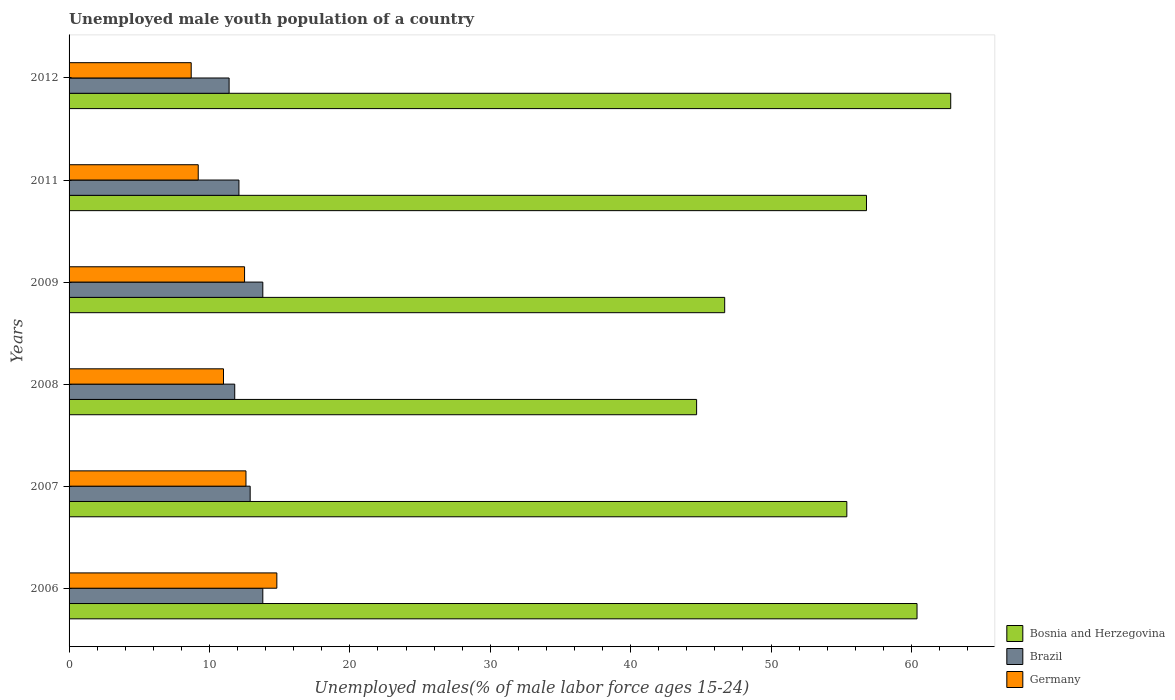How many groups of bars are there?
Ensure brevity in your answer.  6. Are the number of bars per tick equal to the number of legend labels?
Give a very brief answer. Yes. What is the label of the 4th group of bars from the top?
Your response must be concise. 2008. What is the percentage of unemployed male youth population in Bosnia and Herzegovina in 2009?
Offer a terse response. 46.7. Across all years, what is the maximum percentage of unemployed male youth population in Brazil?
Offer a very short reply. 13.8. Across all years, what is the minimum percentage of unemployed male youth population in Bosnia and Herzegovina?
Give a very brief answer. 44.7. In which year was the percentage of unemployed male youth population in Brazil maximum?
Ensure brevity in your answer.  2006. What is the total percentage of unemployed male youth population in Brazil in the graph?
Provide a short and direct response. 75.8. What is the difference between the percentage of unemployed male youth population in Brazil in 2008 and that in 2011?
Provide a short and direct response. -0.3. What is the difference between the percentage of unemployed male youth population in Brazil in 2011 and the percentage of unemployed male youth population in Bosnia and Herzegovina in 2007?
Your answer should be very brief. -43.3. What is the average percentage of unemployed male youth population in Germany per year?
Your answer should be very brief. 11.47. In the year 2012, what is the difference between the percentage of unemployed male youth population in Brazil and percentage of unemployed male youth population in Bosnia and Herzegovina?
Your answer should be very brief. -51.4. In how many years, is the percentage of unemployed male youth population in Bosnia and Herzegovina greater than 32 %?
Keep it short and to the point. 6. What is the ratio of the percentage of unemployed male youth population in Brazil in 2006 to that in 2008?
Make the answer very short. 1.17. What is the difference between the highest and the second highest percentage of unemployed male youth population in Bosnia and Herzegovina?
Your answer should be very brief. 2.4. What is the difference between the highest and the lowest percentage of unemployed male youth population in Bosnia and Herzegovina?
Provide a short and direct response. 18.1. In how many years, is the percentage of unemployed male youth population in Germany greater than the average percentage of unemployed male youth population in Germany taken over all years?
Offer a terse response. 3. Is the sum of the percentage of unemployed male youth population in Bosnia and Herzegovina in 2006 and 2009 greater than the maximum percentage of unemployed male youth population in Germany across all years?
Your answer should be very brief. Yes. What does the 2nd bar from the top in 2008 represents?
Give a very brief answer. Brazil. Are all the bars in the graph horizontal?
Your response must be concise. Yes. How many years are there in the graph?
Offer a very short reply. 6. What is the difference between two consecutive major ticks on the X-axis?
Offer a terse response. 10. Are the values on the major ticks of X-axis written in scientific E-notation?
Keep it short and to the point. No. Does the graph contain any zero values?
Give a very brief answer. No. Does the graph contain grids?
Offer a very short reply. No. What is the title of the graph?
Ensure brevity in your answer.  Unemployed male youth population of a country. What is the label or title of the X-axis?
Your response must be concise. Unemployed males(% of male labor force ages 15-24). What is the label or title of the Y-axis?
Make the answer very short. Years. What is the Unemployed males(% of male labor force ages 15-24) of Bosnia and Herzegovina in 2006?
Your response must be concise. 60.4. What is the Unemployed males(% of male labor force ages 15-24) of Brazil in 2006?
Your answer should be very brief. 13.8. What is the Unemployed males(% of male labor force ages 15-24) of Germany in 2006?
Give a very brief answer. 14.8. What is the Unemployed males(% of male labor force ages 15-24) of Bosnia and Herzegovina in 2007?
Offer a very short reply. 55.4. What is the Unemployed males(% of male labor force ages 15-24) of Brazil in 2007?
Make the answer very short. 12.9. What is the Unemployed males(% of male labor force ages 15-24) in Germany in 2007?
Keep it short and to the point. 12.6. What is the Unemployed males(% of male labor force ages 15-24) in Bosnia and Herzegovina in 2008?
Offer a terse response. 44.7. What is the Unemployed males(% of male labor force ages 15-24) in Brazil in 2008?
Give a very brief answer. 11.8. What is the Unemployed males(% of male labor force ages 15-24) in Germany in 2008?
Offer a terse response. 11. What is the Unemployed males(% of male labor force ages 15-24) of Bosnia and Herzegovina in 2009?
Your answer should be compact. 46.7. What is the Unemployed males(% of male labor force ages 15-24) in Brazil in 2009?
Your answer should be compact. 13.8. What is the Unemployed males(% of male labor force ages 15-24) of Germany in 2009?
Provide a short and direct response. 12.5. What is the Unemployed males(% of male labor force ages 15-24) of Bosnia and Herzegovina in 2011?
Your answer should be compact. 56.8. What is the Unemployed males(% of male labor force ages 15-24) in Brazil in 2011?
Provide a short and direct response. 12.1. What is the Unemployed males(% of male labor force ages 15-24) of Germany in 2011?
Offer a terse response. 9.2. What is the Unemployed males(% of male labor force ages 15-24) of Bosnia and Herzegovina in 2012?
Make the answer very short. 62.8. What is the Unemployed males(% of male labor force ages 15-24) of Brazil in 2012?
Provide a succinct answer. 11.4. What is the Unemployed males(% of male labor force ages 15-24) of Germany in 2012?
Keep it short and to the point. 8.7. Across all years, what is the maximum Unemployed males(% of male labor force ages 15-24) of Bosnia and Herzegovina?
Your answer should be very brief. 62.8. Across all years, what is the maximum Unemployed males(% of male labor force ages 15-24) in Brazil?
Make the answer very short. 13.8. Across all years, what is the maximum Unemployed males(% of male labor force ages 15-24) in Germany?
Your response must be concise. 14.8. Across all years, what is the minimum Unemployed males(% of male labor force ages 15-24) in Bosnia and Herzegovina?
Give a very brief answer. 44.7. Across all years, what is the minimum Unemployed males(% of male labor force ages 15-24) in Brazil?
Offer a very short reply. 11.4. Across all years, what is the minimum Unemployed males(% of male labor force ages 15-24) of Germany?
Ensure brevity in your answer.  8.7. What is the total Unemployed males(% of male labor force ages 15-24) in Bosnia and Herzegovina in the graph?
Offer a terse response. 326.8. What is the total Unemployed males(% of male labor force ages 15-24) in Brazil in the graph?
Ensure brevity in your answer.  75.8. What is the total Unemployed males(% of male labor force ages 15-24) of Germany in the graph?
Your answer should be very brief. 68.8. What is the difference between the Unemployed males(% of male labor force ages 15-24) of Bosnia and Herzegovina in 2006 and that in 2007?
Your answer should be compact. 5. What is the difference between the Unemployed males(% of male labor force ages 15-24) of Bosnia and Herzegovina in 2006 and that in 2008?
Give a very brief answer. 15.7. What is the difference between the Unemployed males(% of male labor force ages 15-24) of Germany in 2006 and that in 2008?
Provide a succinct answer. 3.8. What is the difference between the Unemployed males(% of male labor force ages 15-24) of Brazil in 2006 and that in 2009?
Give a very brief answer. 0. What is the difference between the Unemployed males(% of male labor force ages 15-24) in Germany in 2006 and that in 2011?
Offer a terse response. 5.6. What is the difference between the Unemployed males(% of male labor force ages 15-24) in Bosnia and Herzegovina in 2006 and that in 2012?
Give a very brief answer. -2.4. What is the difference between the Unemployed males(% of male labor force ages 15-24) in Bosnia and Herzegovina in 2007 and that in 2008?
Give a very brief answer. 10.7. What is the difference between the Unemployed males(% of male labor force ages 15-24) in Brazil in 2007 and that in 2008?
Ensure brevity in your answer.  1.1. What is the difference between the Unemployed males(% of male labor force ages 15-24) in Germany in 2007 and that in 2008?
Offer a very short reply. 1.6. What is the difference between the Unemployed males(% of male labor force ages 15-24) in Brazil in 2007 and that in 2009?
Offer a terse response. -0.9. What is the difference between the Unemployed males(% of male labor force ages 15-24) in Germany in 2007 and that in 2009?
Ensure brevity in your answer.  0.1. What is the difference between the Unemployed males(% of male labor force ages 15-24) in Brazil in 2007 and that in 2011?
Provide a short and direct response. 0.8. What is the difference between the Unemployed males(% of male labor force ages 15-24) in Germany in 2007 and that in 2011?
Your response must be concise. 3.4. What is the difference between the Unemployed males(% of male labor force ages 15-24) in Bosnia and Herzegovina in 2007 and that in 2012?
Keep it short and to the point. -7.4. What is the difference between the Unemployed males(% of male labor force ages 15-24) in Germany in 2007 and that in 2012?
Keep it short and to the point. 3.9. What is the difference between the Unemployed males(% of male labor force ages 15-24) in Brazil in 2008 and that in 2009?
Your answer should be very brief. -2. What is the difference between the Unemployed males(% of male labor force ages 15-24) of Germany in 2008 and that in 2009?
Your response must be concise. -1.5. What is the difference between the Unemployed males(% of male labor force ages 15-24) in Bosnia and Herzegovina in 2008 and that in 2011?
Keep it short and to the point. -12.1. What is the difference between the Unemployed males(% of male labor force ages 15-24) of Brazil in 2008 and that in 2011?
Provide a succinct answer. -0.3. What is the difference between the Unemployed males(% of male labor force ages 15-24) of Bosnia and Herzegovina in 2008 and that in 2012?
Your response must be concise. -18.1. What is the difference between the Unemployed males(% of male labor force ages 15-24) in Bosnia and Herzegovina in 2009 and that in 2011?
Offer a terse response. -10.1. What is the difference between the Unemployed males(% of male labor force ages 15-24) of Brazil in 2009 and that in 2011?
Your answer should be compact. 1.7. What is the difference between the Unemployed males(% of male labor force ages 15-24) in Bosnia and Herzegovina in 2009 and that in 2012?
Offer a very short reply. -16.1. What is the difference between the Unemployed males(% of male labor force ages 15-24) in Germany in 2009 and that in 2012?
Keep it short and to the point. 3.8. What is the difference between the Unemployed males(% of male labor force ages 15-24) in Germany in 2011 and that in 2012?
Provide a succinct answer. 0.5. What is the difference between the Unemployed males(% of male labor force ages 15-24) of Bosnia and Herzegovina in 2006 and the Unemployed males(% of male labor force ages 15-24) of Brazil in 2007?
Provide a succinct answer. 47.5. What is the difference between the Unemployed males(% of male labor force ages 15-24) in Bosnia and Herzegovina in 2006 and the Unemployed males(% of male labor force ages 15-24) in Germany in 2007?
Keep it short and to the point. 47.8. What is the difference between the Unemployed males(% of male labor force ages 15-24) of Brazil in 2006 and the Unemployed males(% of male labor force ages 15-24) of Germany in 2007?
Make the answer very short. 1.2. What is the difference between the Unemployed males(% of male labor force ages 15-24) in Bosnia and Herzegovina in 2006 and the Unemployed males(% of male labor force ages 15-24) in Brazil in 2008?
Make the answer very short. 48.6. What is the difference between the Unemployed males(% of male labor force ages 15-24) in Bosnia and Herzegovina in 2006 and the Unemployed males(% of male labor force ages 15-24) in Germany in 2008?
Keep it short and to the point. 49.4. What is the difference between the Unemployed males(% of male labor force ages 15-24) in Brazil in 2006 and the Unemployed males(% of male labor force ages 15-24) in Germany in 2008?
Offer a very short reply. 2.8. What is the difference between the Unemployed males(% of male labor force ages 15-24) of Bosnia and Herzegovina in 2006 and the Unemployed males(% of male labor force ages 15-24) of Brazil in 2009?
Your response must be concise. 46.6. What is the difference between the Unemployed males(% of male labor force ages 15-24) of Bosnia and Herzegovina in 2006 and the Unemployed males(% of male labor force ages 15-24) of Germany in 2009?
Provide a succinct answer. 47.9. What is the difference between the Unemployed males(% of male labor force ages 15-24) of Brazil in 2006 and the Unemployed males(% of male labor force ages 15-24) of Germany in 2009?
Provide a succinct answer. 1.3. What is the difference between the Unemployed males(% of male labor force ages 15-24) of Bosnia and Herzegovina in 2006 and the Unemployed males(% of male labor force ages 15-24) of Brazil in 2011?
Offer a very short reply. 48.3. What is the difference between the Unemployed males(% of male labor force ages 15-24) of Bosnia and Herzegovina in 2006 and the Unemployed males(% of male labor force ages 15-24) of Germany in 2011?
Provide a short and direct response. 51.2. What is the difference between the Unemployed males(% of male labor force ages 15-24) of Bosnia and Herzegovina in 2006 and the Unemployed males(% of male labor force ages 15-24) of Brazil in 2012?
Keep it short and to the point. 49. What is the difference between the Unemployed males(% of male labor force ages 15-24) of Bosnia and Herzegovina in 2006 and the Unemployed males(% of male labor force ages 15-24) of Germany in 2012?
Keep it short and to the point. 51.7. What is the difference between the Unemployed males(% of male labor force ages 15-24) of Bosnia and Herzegovina in 2007 and the Unemployed males(% of male labor force ages 15-24) of Brazil in 2008?
Offer a very short reply. 43.6. What is the difference between the Unemployed males(% of male labor force ages 15-24) of Bosnia and Herzegovina in 2007 and the Unemployed males(% of male labor force ages 15-24) of Germany in 2008?
Your answer should be very brief. 44.4. What is the difference between the Unemployed males(% of male labor force ages 15-24) in Brazil in 2007 and the Unemployed males(% of male labor force ages 15-24) in Germany in 2008?
Make the answer very short. 1.9. What is the difference between the Unemployed males(% of male labor force ages 15-24) of Bosnia and Herzegovina in 2007 and the Unemployed males(% of male labor force ages 15-24) of Brazil in 2009?
Provide a succinct answer. 41.6. What is the difference between the Unemployed males(% of male labor force ages 15-24) in Bosnia and Herzegovina in 2007 and the Unemployed males(% of male labor force ages 15-24) in Germany in 2009?
Keep it short and to the point. 42.9. What is the difference between the Unemployed males(% of male labor force ages 15-24) of Bosnia and Herzegovina in 2007 and the Unemployed males(% of male labor force ages 15-24) of Brazil in 2011?
Provide a short and direct response. 43.3. What is the difference between the Unemployed males(% of male labor force ages 15-24) of Bosnia and Herzegovina in 2007 and the Unemployed males(% of male labor force ages 15-24) of Germany in 2011?
Your answer should be compact. 46.2. What is the difference between the Unemployed males(% of male labor force ages 15-24) of Bosnia and Herzegovina in 2007 and the Unemployed males(% of male labor force ages 15-24) of Germany in 2012?
Make the answer very short. 46.7. What is the difference between the Unemployed males(% of male labor force ages 15-24) in Brazil in 2007 and the Unemployed males(% of male labor force ages 15-24) in Germany in 2012?
Offer a very short reply. 4.2. What is the difference between the Unemployed males(% of male labor force ages 15-24) of Bosnia and Herzegovina in 2008 and the Unemployed males(% of male labor force ages 15-24) of Brazil in 2009?
Make the answer very short. 30.9. What is the difference between the Unemployed males(% of male labor force ages 15-24) in Bosnia and Herzegovina in 2008 and the Unemployed males(% of male labor force ages 15-24) in Germany in 2009?
Make the answer very short. 32.2. What is the difference between the Unemployed males(% of male labor force ages 15-24) of Bosnia and Herzegovina in 2008 and the Unemployed males(% of male labor force ages 15-24) of Brazil in 2011?
Provide a succinct answer. 32.6. What is the difference between the Unemployed males(% of male labor force ages 15-24) in Bosnia and Herzegovina in 2008 and the Unemployed males(% of male labor force ages 15-24) in Germany in 2011?
Offer a very short reply. 35.5. What is the difference between the Unemployed males(% of male labor force ages 15-24) in Bosnia and Herzegovina in 2008 and the Unemployed males(% of male labor force ages 15-24) in Brazil in 2012?
Your answer should be very brief. 33.3. What is the difference between the Unemployed males(% of male labor force ages 15-24) of Brazil in 2008 and the Unemployed males(% of male labor force ages 15-24) of Germany in 2012?
Keep it short and to the point. 3.1. What is the difference between the Unemployed males(% of male labor force ages 15-24) in Bosnia and Herzegovina in 2009 and the Unemployed males(% of male labor force ages 15-24) in Brazil in 2011?
Give a very brief answer. 34.6. What is the difference between the Unemployed males(% of male labor force ages 15-24) of Bosnia and Herzegovina in 2009 and the Unemployed males(% of male labor force ages 15-24) of Germany in 2011?
Your answer should be very brief. 37.5. What is the difference between the Unemployed males(% of male labor force ages 15-24) in Brazil in 2009 and the Unemployed males(% of male labor force ages 15-24) in Germany in 2011?
Provide a short and direct response. 4.6. What is the difference between the Unemployed males(% of male labor force ages 15-24) of Bosnia and Herzegovina in 2009 and the Unemployed males(% of male labor force ages 15-24) of Brazil in 2012?
Your response must be concise. 35.3. What is the difference between the Unemployed males(% of male labor force ages 15-24) of Bosnia and Herzegovina in 2009 and the Unemployed males(% of male labor force ages 15-24) of Germany in 2012?
Give a very brief answer. 38. What is the difference between the Unemployed males(% of male labor force ages 15-24) of Brazil in 2009 and the Unemployed males(% of male labor force ages 15-24) of Germany in 2012?
Your answer should be very brief. 5.1. What is the difference between the Unemployed males(% of male labor force ages 15-24) in Bosnia and Herzegovina in 2011 and the Unemployed males(% of male labor force ages 15-24) in Brazil in 2012?
Provide a short and direct response. 45.4. What is the difference between the Unemployed males(% of male labor force ages 15-24) of Bosnia and Herzegovina in 2011 and the Unemployed males(% of male labor force ages 15-24) of Germany in 2012?
Make the answer very short. 48.1. What is the difference between the Unemployed males(% of male labor force ages 15-24) of Brazil in 2011 and the Unemployed males(% of male labor force ages 15-24) of Germany in 2012?
Offer a terse response. 3.4. What is the average Unemployed males(% of male labor force ages 15-24) in Bosnia and Herzegovina per year?
Give a very brief answer. 54.47. What is the average Unemployed males(% of male labor force ages 15-24) in Brazil per year?
Provide a succinct answer. 12.63. What is the average Unemployed males(% of male labor force ages 15-24) of Germany per year?
Provide a short and direct response. 11.47. In the year 2006, what is the difference between the Unemployed males(% of male labor force ages 15-24) of Bosnia and Herzegovina and Unemployed males(% of male labor force ages 15-24) of Brazil?
Ensure brevity in your answer.  46.6. In the year 2006, what is the difference between the Unemployed males(% of male labor force ages 15-24) of Bosnia and Herzegovina and Unemployed males(% of male labor force ages 15-24) of Germany?
Ensure brevity in your answer.  45.6. In the year 2007, what is the difference between the Unemployed males(% of male labor force ages 15-24) of Bosnia and Herzegovina and Unemployed males(% of male labor force ages 15-24) of Brazil?
Your answer should be compact. 42.5. In the year 2007, what is the difference between the Unemployed males(% of male labor force ages 15-24) in Bosnia and Herzegovina and Unemployed males(% of male labor force ages 15-24) in Germany?
Offer a terse response. 42.8. In the year 2007, what is the difference between the Unemployed males(% of male labor force ages 15-24) of Brazil and Unemployed males(% of male labor force ages 15-24) of Germany?
Your answer should be very brief. 0.3. In the year 2008, what is the difference between the Unemployed males(% of male labor force ages 15-24) in Bosnia and Herzegovina and Unemployed males(% of male labor force ages 15-24) in Brazil?
Ensure brevity in your answer.  32.9. In the year 2008, what is the difference between the Unemployed males(% of male labor force ages 15-24) of Bosnia and Herzegovina and Unemployed males(% of male labor force ages 15-24) of Germany?
Provide a short and direct response. 33.7. In the year 2008, what is the difference between the Unemployed males(% of male labor force ages 15-24) of Brazil and Unemployed males(% of male labor force ages 15-24) of Germany?
Ensure brevity in your answer.  0.8. In the year 2009, what is the difference between the Unemployed males(% of male labor force ages 15-24) in Bosnia and Herzegovina and Unemployed males(% of male labor force ages 15-24) in Brazil?
Make the answer very short. 32.9. In the year 2009, what is the difference between the Unemployed males(% of male labor force ages 15-24) of Bosnia and Herzegovina and Unemployed males(% of male labor force ages 15-24) of Germany?
Provide a short and direct response. 34.2. In the year 2009, what is the difference between the Unemployed males(% of male labor force ages 15-24) in Brazil and Unemployed males(% of male labor force ages 15-24) in Germany?
Provide a succinct answer. 1.3. In the year 2011, what is the difference between the Unemployed males(% of male labor force ages 15-24) of Bosnia and Herzegovina and Unemployed males(% of male labor force ages 15-24) of Brazil?
Ensure brevity in your answer.  44.7. In the year 2011, what is the difference between the Unemployed males(% of male labor force ages 15-24) in Bosnia and Herzegovina and Unemployed males(% of male labor force ages 15-24) in Germany?
Make the answer very short. 47.6. In the year 2012, what is the difference between the Unemployed males(% of male labor force ages 15-24) of Bosnia and Herzegovina and Unemployed males(% of male labor force ages 15-24) of Brazil?
Ensure brevity in your answer.  51.4. In the year 2012, what is the difference between the Unemployed males(% of male labor force ages 15-24) in Bosnia and Herzegovina and Unemployed males(% of male labor force ages 15-24) in Germany?
Your answer should be very brief. 54.1. In the year 2012, what is the difference between the Unemployed males(% of male labor force ages 15-24) in Brazil and Unemployed males(% of male labor force ages 15-24) in Germany?
Your answer should be compact. 2.7. What is the ratio of the Unemployed males(% of male labor force ages 15-24) in Bosnia and Herzegovina in 2006 to that in 2007?
Give a very brief answer. 1.09. What is the ratio of the Unemployed males(% of male labor force ages 15-24) of Brazil in 2006 to that in 2007?
Make the answer very short. 1.07. What is the ratio of the Unemployed males(% of male labor force ages 15-24) of Germany in 2006 to that in 2007?
Keep it short and to the point. 1.17. What is the ratio of the Unemployed males(% of male labor force ages 15-24) of Bosnia and Herzegovina in 2006 to that in 2008?
Your answer should be very brief. 1.35. What is the ratio of the Unemployed males(% of male labor force ages 15-24) in Brazil in 2006 to that in 2008?
Ensure brevity in your answer.  1.17. What is the ratio of the Unemployed males(% of male labor force ages 15-24) in Germany in 2006 to that in 2008?
Offer a terse response. 1.35. What is the ratio of the Unemployed males(% of male labor force ages 15-24) in Bosnia and Herzegovina in 2006 to that in 2009?
Offer a terse response. 1.29. What is the ratio of the Unemployed males(% of male labor force ages 15-24) in Brazil in 2006 to that in 2009?
Make the answer very short. 1. What is the ratio of the Unemployed males(% of male labor force ages 15-24) of Germany in 2006 to that in 2009?
Keep it short and to the point. 1.18. What is the ratio of the Unemployed males(% of male labor force ages 15-24) in Bosnia and Herzegovina in 2006 to that in 2011?
Offer a terse response. 1.06. What is the ratio of the Unemployed males(% of male labor force ages 15-24) in Brazil in 2006 to that in 2011?
Make the answer very short. 1.14. What is the ratio of the Unemployed males(% of male labor force ages 15-24) in Germany in 2006 to that in 2011?
Keep it short and to the point. 1.61. What is the ratio of the Unemployed males(% of male labor force ages 15-24) of Bosnia and Herzegovina in 2006 to that in 2012?
Your response must be concise. 0.96. What is the ratio of the Unemployed males(% of male labor force ages 15-24) of Brazil in 2006 to that in 2012?
Provide a succinct answer. 1.21. What is the ratio of the Unemployed males(% of male labor force ages 15-24) in Germany in 2006 to that in 2012?
Offer a very short reply. 1.7. What is the ratio of the Unemployed males(% of male labor force ages 15-24) of Bosnia and Herzegovina in 2007 to that in 2008?
Make the answer very short. 1.24. What is the ratio of the Unemployed males(% of male labor force ages 15-24) of Brazil in 2007 to that in 2008?
Keep it short and to the point. 1.09. What is the ratio of the Unemployed males(% of male labor force ages 15-24) of Germany in 2007 to that in 2008?
Provide a short and direct response. 1.15. What is the ratio of the Unemployed males(% of male labor force ages 15-24) in Bosnia and Herzegovina in 2007 to that in 2009?
Ensure brevity in your answer.  1.19. What is the ratio of the Unemployed males(% of male labor force ages 15-24) in Brazil in 2007 to that in 2009?
Provide a succinct answer. 0.93. What is the ratio of the Unemployed males(% of male labor force ages 15-24) in Bosnia and Herzegovina in 2007 to that in 2011?
Keep it short and to the point. 0.98. What is the ratio of the Unemployed males(% of male labor force ages 15-24) of Brazil in 2007 to that in 2011?
Provide a short and direct response. 1.07. What is the ratio of the Unemployed males(% of male labor force ages 15-24) of Germany in 2007 to that in 2011?
Offer a very short reply. 1.37. What is the ratio of the Unemployed males(% of male labor force ages 15-24) in Bosnia and Herzegovina in 2007 to that in 2012?
Provide a succinct answer. 0.88. What is the ratio of the Unemployed males(% of male labor force ages 15-24) of Brazil in 2007 to that in 2012?
Provide a succinct answer. 1.13. What is the ratio of the Unemployed males(% of male labor force ages 15-24) in Germany in 2007 to that in 2012?
Keep it short and to the point. 1.45. What is the ratio of the Unemployed males(% of male labor force ages 15-24) in Bosnia and Herzegovina in 2008 to that in 2009?
Make the answer very short. 0.96. What is the ratio of the Unemployed males(% of male labor force ages 15-24) of Brazil in 2008 to that in 2009?
Give a very brief answer. 0.86. What is the ratio of the Unemployed males(% of male labor force ages 15-24) of Germany in 2008 to that in 2009?
Offer a terse response. 0.88. What is the ratio of the Unemployed males(% of male labor force ages 15-24) in Bosnia and Herzegovina in 2008 to that in 2011?
Keep it short and to the point. 0.79. What is the ratio of the Unemployed males(% of male labor force ages 15-24) in Brazil in 2008 to that in 2011?
Make the answer very short. 0.98. What is the ratio of the Unemployed males(% of male labor force ages 15-24) of Germany in 2008 to that in 2011?
Your response must be concise. 1.2. What is the ratio of the Unemployed males(% of male labor force ages 15-24) of Bosnia and Herzegovina in 2008 to that in 2012?
Offer a terse response. 0.71. What is the ratio of the Unemployed males(% of male labor force ages 15-24) of Brazil in 2008 to that in 2012?
Give a very brief answer. 1.04. What is the ratio of the Unemployed males(% of male labor force ages 15-24) of Germany in 2008 to that in 2012?
Offer a very short reply. 1.26. What is the ratio of the Unemployed males(% of male labor force ages 15-24) of Bosnia and Herzegovina in 2009 to that in 2011?
Your response must be concise. 0.82. What is the ratio of the Unemployed males(% of male labor force ages 15-24) in Brazil in 2009 to that in 2011?
Ensure brevity in your answer.  1.14. What is the ratio of the Unemployed males(% of male labor force ages 15-24) of Germany in 2009 to that in 2011?
Your answer should be compact. 1.36. What is the ratio of the Unemployed males(% of male labor force ages 15-24) in Bosnia and Herzegovina in 2009 to that in 2012?
Offer a very short reply. 0.74. What is the ratio of the Unemployed males(% of male labor force ages 15-24) of Brazil in 2009 to that in 2012?
Your answer should be very brief. 1.21. What is the ratio of the Unemployed males(% of male labor force ages 15-24) in Germany in 2009 to that in 2012?
Give a very brief answer. 1.44. What is the ratio of the Unemployed males(% of male labor force ages 15-24) of Bosnia and Herzegovina in 2011 to that in 2012?
Ensure brevity in your answer.  0.9. What is the ratio of the Unemployed males(% of male labor force ages 15-24) of Brazil in 2011 to that in 2012?
Keep it short and to the point. 1.06. What is the ratio of the Unemployed males(% of male labor force ages 15-24) in Germany in 2011 to that in 2012?
Keep it short and to the point. 1.06. What is the difference between the highest and the second highest Unemployed males(% of male labor force ages 15-24) of Germany?
Keep it short and to the point. 2.2. What is the difference between the highest and the lowest Unemployed males(% of male labor force ages 15-24) in Germany?
Give a very brief answer. 6.1. 